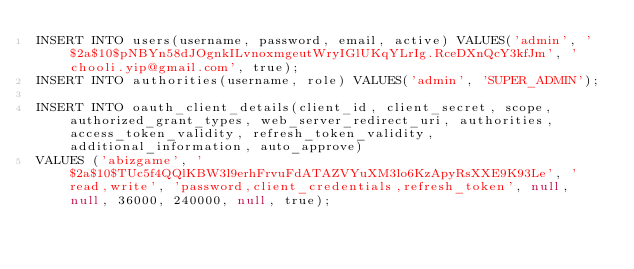<code> <loc_0><loc_0><loc_500><loc_500><_SQL_>INSERT INTO users(username, password, email, active) VALUES('admin', '$2a$10$pNBYn58dJOgnkILvnoxmgeutWryIGlUKqYLrIg.RceDXnQcY3kfJm', 'chooli.yip@gmail.com', true);
INSERT INTO authorities(username, role) VALUES('admin', 'SUPER_ADMIN');

INSERT INTO oauth_client_details(client_id, client_secret, scope, authorized_grant_types, web_server_redirect_uri, authorities, access_token_validity, refresh_token_validity, additional_information, auto_approve)
VALUES ('abizgame', '$2a$10$TUc5f4QQlKBW3l9erhFrvuFdATAZVYuXM3lo6KzApyRsXXE9K93Le', 'read,write', 'password,client_credentials,refresh_token', null, null, 36000, 240000, null, true);</code> 